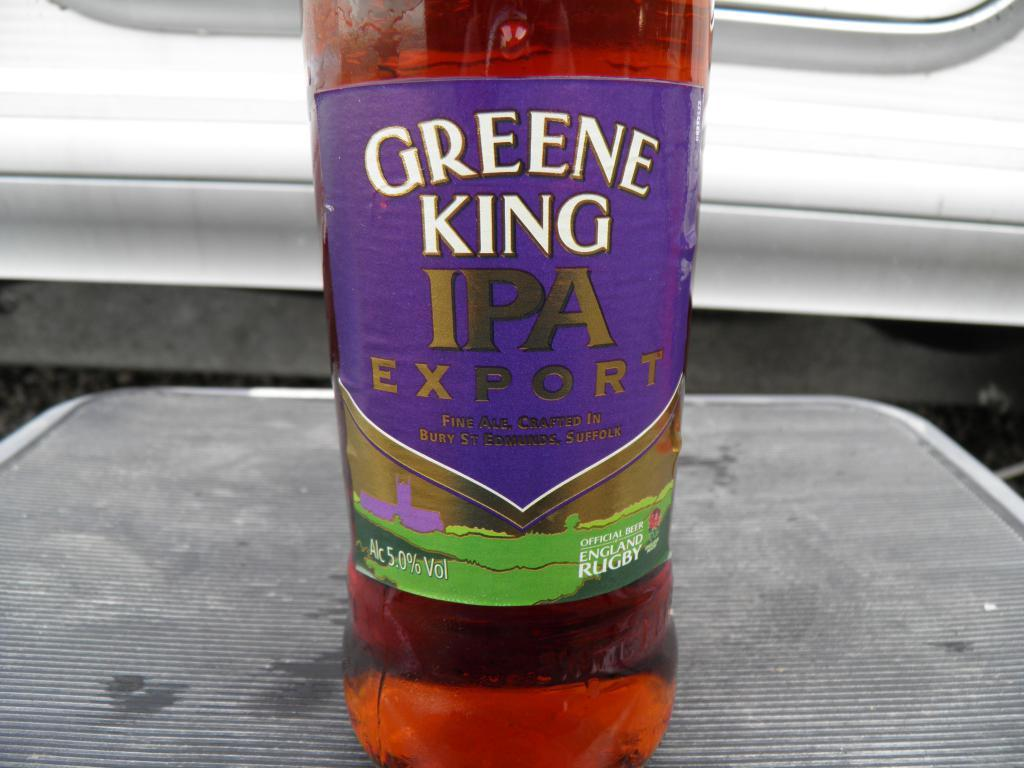<image>
Render a clear and concise summary of the photo. A full bottle of Greene King IPA Export sits on a table. 